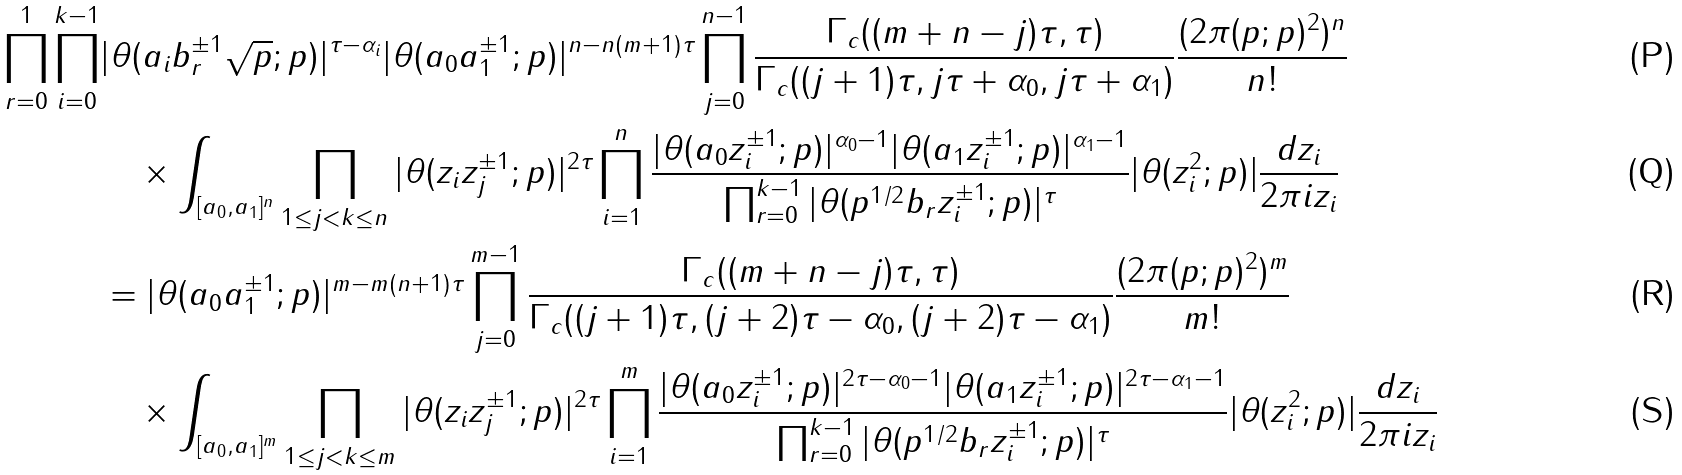Convert formula to latex. <formula><loc_0><loc_0><loc_500><loc_500>\prod _ { r = 0 } ^ { 1 } \prod _ { i = 0 } ^ { k - 1 } & | \theta ( a _ { i } b _ { r } ^ { \pm 1 } \sqrt { p } ; p ) | ^ { \tau - \alpha _ { i } } | \theta ( a _ { 0 } a _ { 1 } ^ { \pm 1 } ; p ) | ^ { n - n ( m + 1 ) \tau } \prod _ { j = 0 } ^ { n - 1 } \frac { \Gamma _ { c } ( ( m + n - j ) \tau , \tau ) } { \Gamma _ { c } ( ( j + 1 ) \tau , j \tau + \alpha _ { 0 } , j \tau + \alpha _ { 1 } ) } \frac { ( 2 \pi ( p ; p ) ^ { 2 } ) ^ { n } } { n ! } \\ & \quad \times \int _ { [ a _ { 0 } , a _ { 1 } ] ^ { n } } \prod _ { 1 \leq j < k \leq n } | \theta ( z _ { i } z _ { j } ^ { \pm 1 } ; p ) | ^ { 2 \tau } \prod _ { i = 1 } ^ { n } \frac { | \theta ( a _ { 0 } z _ { i } ^ { \pm 1 } ; p ) | ^ { \alpha _ { 0 } - 1 } | \theta ( a _ { 1 } z _ { i } ^ { \pm 1 } ; p ) | ^ { \alpha _ { 1 } - 1 } } { \prod _ { r = 0 } ^ { k - 1 } | \theta ( p ^ { 1 / 2 } b _ { r } z _ { i } ^ { \pm 1 } ; p ) | ^ { \tau } } | \theta ( z _ { i } ^ { 2 } ; p ) | \frac { d z _ { i } } { 2 \pi i z _ { i } } \\ & = | \theta ( a _ { 0 } a _ { 1 } ^ { \pm 1 } ; p ) | ^ { m - m ( n + 1 ) \tau } \prod _ { j = 0 } ^ { m - 1 } \frac { \Gamma _ { c } ( ( m + n - j ) \tau , \tau ) } { \Gamma _ { c } ( ( j + 1 ) \tau , ( j + 2 ) \tau - \alpha _ { 0 } , ( j + 2 ) \tau - \alpha _ { 1 } ) } \frac { ( 2 \pi ( p ; p ) ^ { 2 } ) ^ { m } } { m ! } \\ & \quad \times \int _ { [ a _ { 0 } , a _ { 1 } ] ^ { m } } \prod _ { 1 \leq j < k \leq m } | \theta ( z _ { i } z _ { j } ^ { \pm 1 } ; p ) | ^ { 2 \tau } \prod _ { i = 1 } ^ { m } \frac { | \theta ( a _ { 0 } z _ { i } ^ { \pm 1 } ; p ) | ^ { 2 \tau - \alpha _ { 0 } - 1 } | \theta ( a _ { 1 } z _ { i } ^ { \pm 1 } ; p ) | ^ { 2 \tau - \alpha _ { 1 } - 1 } } { \prod _ { r = 0 } ^ { k - 1 } | \theta ( p ^ { 1 / 2 } b _ { r } z _ { i } ^ { \pm 1 } ; p ) | ^ { \tau } } | \theta ( z _ { i } ^ { 2 } ; p ) | \frac { d z _ { i } } { 2 \pi i z _ { i } }</formula> 